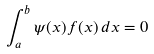Convert formula to latex. <formula><loc_0><loc_0><loc_500><loc_500>\int _ { a } ^ { b } \psi ( x ) f ( x ) \, d x = 0</formula> 